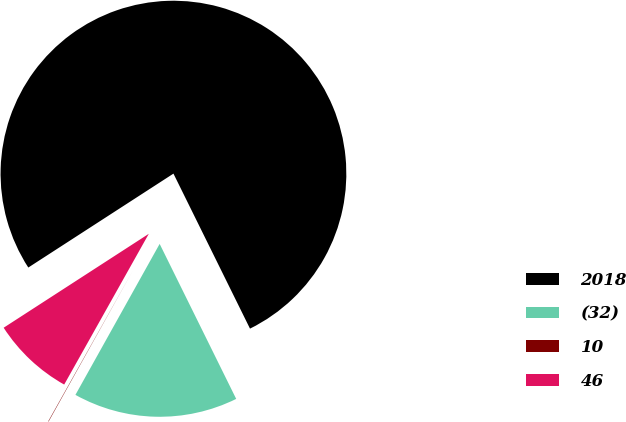<chart> <loc_0><loc_0><loc_500><loc_500><pie_chart><fcel>2018<fcel>(32)<fcel>10<fcel>46<nl><fcel>76.84%<fcel>15.4%<fcel>0.04%<fcel>7.72%<nl></chart> 